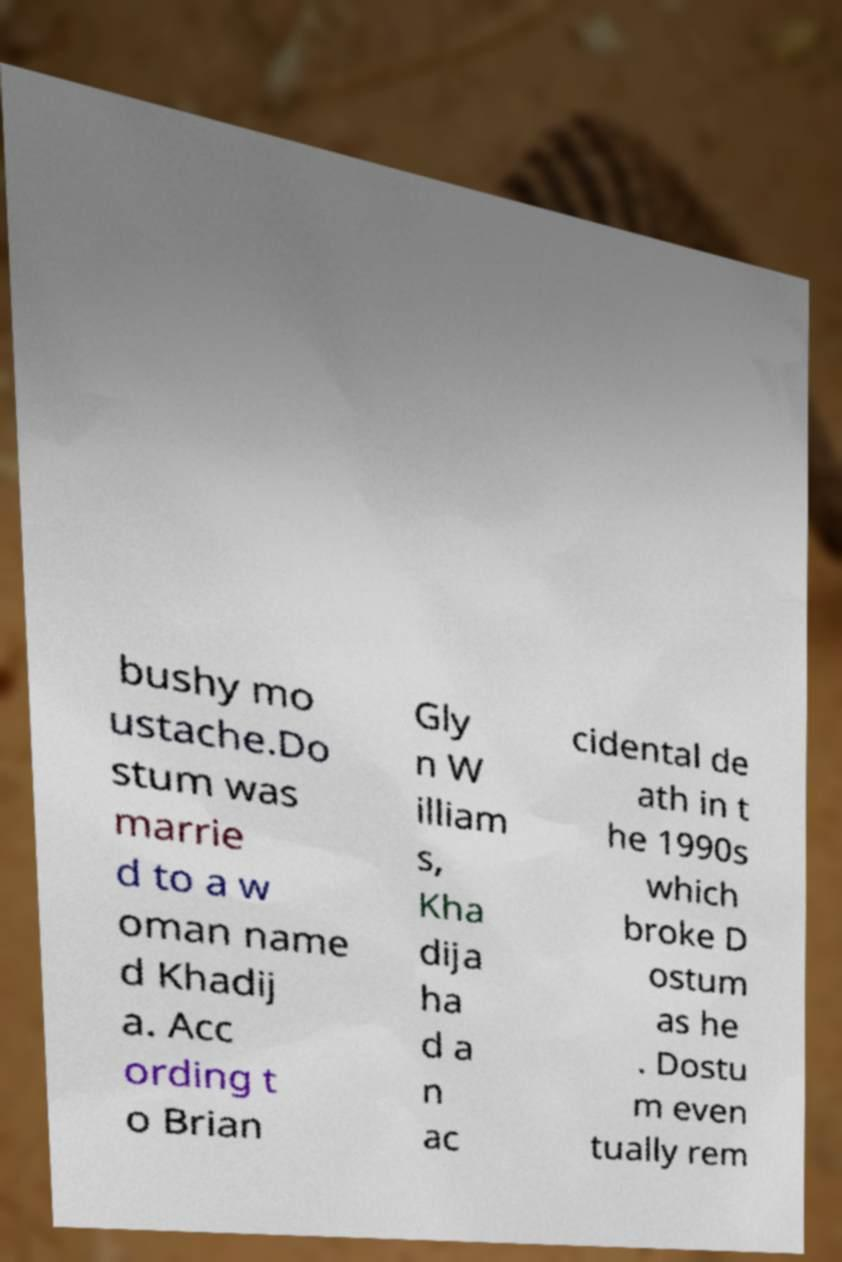Can you read and provide the text displayed in the image?This photo seems to have some interesting text. Can you extract and type it out for me? bushy mo ustache.Do stum was marrie d to a w oman name d Khadij a. Acc ording t o Brian Gly n W illiam s, Kha dija ha d a n ac cidental de ath in t he 1990s which broke D ostum as he . Dostu m even tually rem 